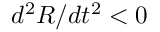<formula> <loc_0><loc_0><loc_500><loc_500>d ^ { 2 } R / d t ^ { 2 } < 0</formula> 